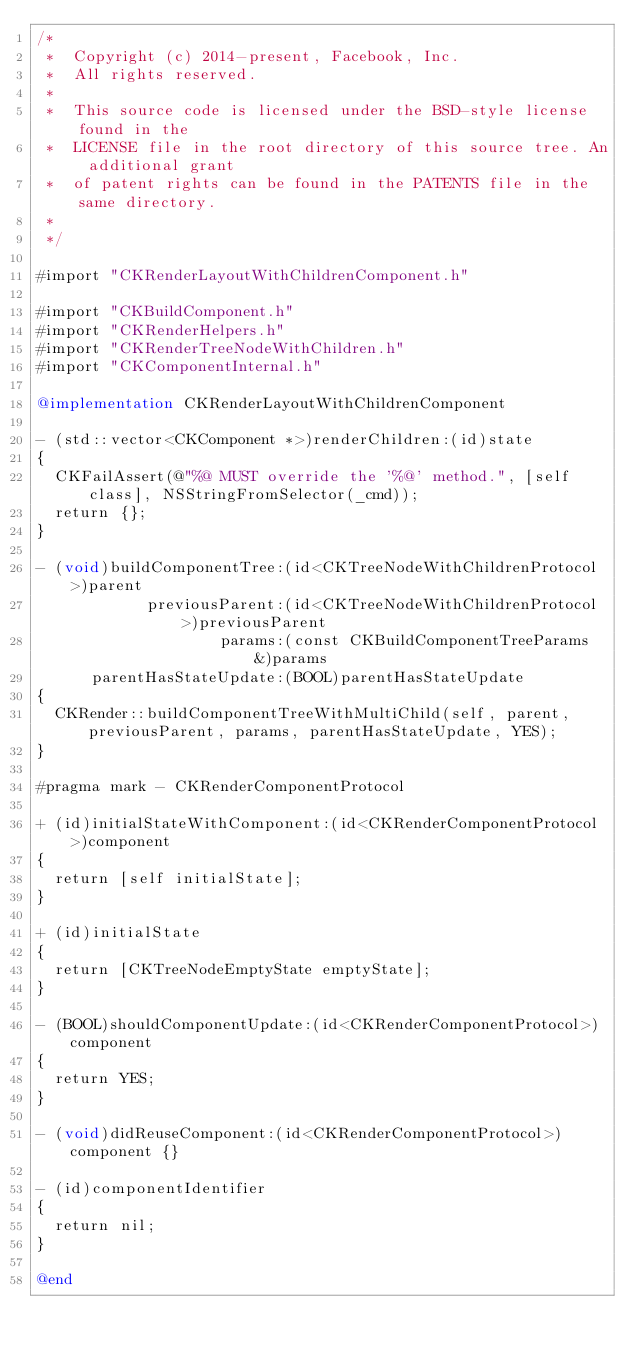Convert code to text. <code><loc_0><loc_0><loc_500><loc_500><_ObjectiveC_>/*
 *  Copyright (c) 2014-present, Facebook, Inc.
 *  All rights reserved.
 *
 *  This source code is licensed under the BSD-style license found in the
 *  LICENSE file in the root directory of this source tree. An additional grant
 *  of patent rights can be found in the PATENTS file in the same directory.
 *
 */

#import "CKRenderLayoutWithChildrenComponent.h"

#import "CKBuildComponent.h"
#import "CKRenderHelpers.h"
#import "CKRenderTreeNodeWithChildren.h"
#import "CKComponentInternal.h"

@implementation CKRenderLayoutWithChildrenComponent

- (std::vector<CKComponent *>)renderChildren:(id)state
{
  CKFailAssert(@"%@ MUST override the '%@' method.", [self class], NSStringFromSelector(_cmd));
  return {};
}

- (void)buildComponentTree:(id<CKTreeNodeWithChildrenProtocol>)parent
            previousParent:(id<CKTreeNodeWithChildrenProtocol>)previousParent
                    params:(const CKBuildComponentTreeParams &)params
      parentHasStateUpdate:(BOOL)parentHasStateUpdate
{
  CKRender::buildComponentTreeWithMultiChild(self, parent, previousParent, params, parentHasStateUpdate, YES);
}

#pragma mark - CKRenderComponentProtocol

+ (id)initialStateWithComponent:(id<CKRenderComponentProtocol>)component
{
  return [self initialState];
}

+ (id)initialState
{
  return [CKTreeNodeEmptyState emptyState];
}

- (BOOL)shouldComponentUpdate:(id<CKRenderComponentProtocol>)component
{
  return YES;
}

- (void)didReuseComponent:(id<CKRenderComponentProtocol>)component {}

- (id)componentIdentifier
{
  return nil;
}

@end
</code> 